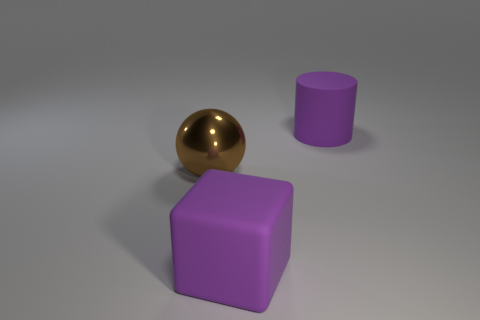Is there anything else of the same color as the block?
Offer a very short reply. Yes. There is a object on the right side of the big rubber object that is in front of the large ball; is there a matte cube to the right of it?
Your response must be concise. No. Do the thing that is in front of the brown metal ball and the matte cylinder have the same color?
Provide a short and direct response. Yes. How many spheres are large purple things or tiny red rubber objects?
Your answer should be compact. 0. There is a large matte object that is in front of the rubber thing behind the big purple rubber block; what shape is it?
Your answer should be compact. Cube. Is the metallic object the same size as the matte cylinder?
Make the answer very short. Yes. How many objects are either large brown metal spheres or large brown rubber cylinders?
Your answer should be compact. 1. The brown metal ball is what size?
Your response must be concise. Large. There is a thing that is in front of the purple cylinder and to the right of the sphere; what shape is it?
Offer a terse response. Cube. What number of objects are either objects right of the brown metal sphere or big things that are behind the brown metal ball?
Your answer should be very brief. 2. 